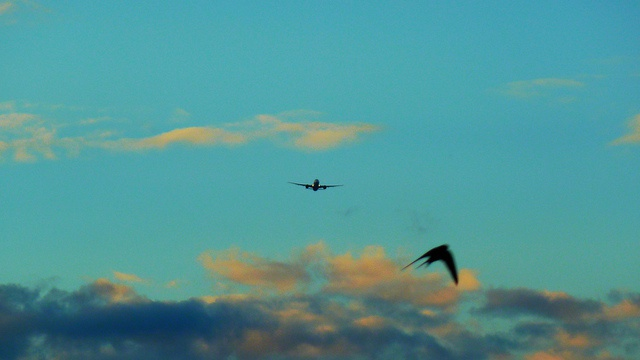Describe the objects in this image and their specific colors. I can see bird in teal and black tones and airplane in teal and black tones in this image. 